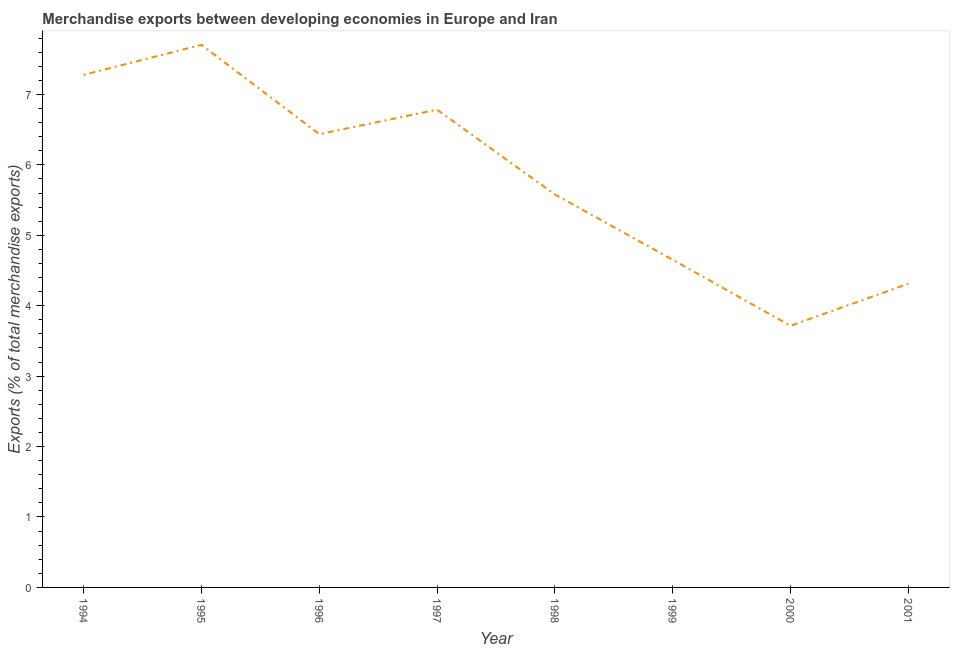What is the merchandise exports in 1994?
Make the answer very short. 7.28. Across all years, what is the maximum merchandise exports?
Your answer should be compact. 7.7. Across all years, what is the minimum merchandise exports?
Ensure brevity in your answer.  3.71. What is the sum of the merchandise exports?
Make the answer very short. 46.46. What is the difference between the merchandise exports in 1994 and 1998?
Provide a succinct answer. 1.7. What is the average merchandise exports per year?
Provide a short and direct response. 5.81. What is the median merchandise exports?
Ensure brevity in your answer.  6.01. In how many years, is the merchandise exports greater than 3.2 %?
Your answer should be very brief. 8. Do a majority of the years between 1999 and 1994 (inclusive) have merchandise exports greater than 6.6 %?
Your response must be concise. Yes. What is the ratio of the merchandise exports in 1995 to that in 2000?
Offer a terse response. 2.07. What is the difference between the highest and the second highest merchandise exports?
Offer a terse response. 0.43. What is the difference between the highest and the lowest merchandise exports?
Provide a succinct answer. 3.99. In how many years, is the merchandise exports greater than the average merchandise exports taken over all years?
Keep it short and to the point. 4. How many lines are there?
Provide a short and direct response. 1. How many years are there in the graph?
Your answer should be very brief. 8. Does the graph contain any zero values?
Your response must be concise. No. What is the title of the graph?
Your response must be concise. Merchandise exports between developing economies in Europe and Iran. What is the label or title of the Y-axis?
Make the answer very short. Exports (% of total merchandise exports). What is the Exports (% of total merchandise exports) of 1994?
Your response must be concise. 7.28. What is the Exports (% of total merchandise exports) of 1995?
Your response must be concise. 7.7. What is the Exports (% of total merchandise exports) in 1996?
Offer a very short reply. 6.44. What is the Exports (% of total merchandise exports) in 1997?
Give a very brief answer. 6.78. What is the Exports (% of total merchandise exports) in 1998?
Provide a short and direct response. 5.58. What is the Exports (% of total merchandise exports) of 1999?
Provide a succinct answer. 4.65. What is the Exports (% of total merchandise exports) in 2000?
Offer a very short reply. 3.71. What is the Exports (% of total merchandise exports) in 2001?
Your answer should be very brief. 4.31. What is the difference between the Exports (% of total merchandise exports) in 1994 and 1995?
Provide a short and direct response. -0.43. What is the difference between the Exports (% of total merchandise exports) in 1994 and 1996?
Offer a very short reply. 0.84. What is the difference between the Exports (% of total merchandise exports) in 1994 and 1997?
Offer a terse response. 0.49. What is the difference between the Exports (% of total merchandise exports) in 1994 and 1998?
Your response must be concise. 1.7. What is the difference between the Exports (% of total merchandise exports) in 1994 and 1999?
Keep it short and to the point. 2.63. What is the difference between the Exports (% of total merchandise exports) in 1994 and 2000?
Your answer should be very brief. 3.56. What is the difference between the Exports (% of total merchandise exports) in 1994 and 2001?
Provide a succinct answer. 2.97. What is the difference between the Exports (% of total merchandise exports) in 1995 and 1996?
Make the answer very short. 1.27. What is the difference between the Exports (% of total merchandise exports) in 1995 and 1997?
Provide a short and direct response. 0.92. What is the difference between the Exports (% of total merchandise exports) in 1995 and 1998?
Give a very brief answer. 2.12. What is the difference between the Exports (% of total merchandise exports) in 1995 and 1999?
Your answer should be compact. 3.05. What is the difference between the Exports (% of total merchandise exports) in 1995 and 2000?
Provide a short and direct response. 3.99. What is the difference between the Exports (% of total merchandise exports) in 1995 and 2001?
Offer a terse response. 3.39. What is the difference between the Exports (% of total merchandise exports) in 1996 and 1997?
Your answer should be compact. -0.35. What is the difference between the Exports (% of total merchandise exports) in 1996 and 1998?
Your answer should be compact. 0.86. What is the difference between the Exports (% of total merchandise exports) in 1996 and 1999?
Your answer should be compact. 1.78. What is the difference between the Exports (% of total merchandise exports) in 1996 and 2000?
Offer a terse response. 2.72. What is the difference between the Exports (% of total merchandise exports) in 1996 and 2001?
Make the answer very short. 2.13. What is the difference between the Exports (% of total merchandise exports) in 1997 and 1998?
Ensure brevity in your answer.  1.2. What is the difference between the Exports (% of total merchandise exports) in 1997 and 1999?
Ensure brevity in your answer.  2.13. What is the difference between the Exports (% of total merchandise exports) in 1997 and 2000?
Keep it short and to the point. 3.07. What is the difference between the Exports (% of total merchandise exports) in 1997 and 2001?
Offer a terse response. 2.47. What is the difference between the Exports (% of total merchandise exports) in 1998 and 1999?
Ensure brevity in your answer.  0.93. What is the difference between the Exports (% of total merchandise exports) in 1998 and 2000?
Make the answer very short. 1.87. What is the difference between the Exports (% of total merchandise exports) in 1998 and 2001?
Your answer should be very brief. 1.27. What is the difference between the Exports (% of total merchandise exports) in 1999 and 2000?
Provide a short and direct response. 0.94. What is the difference between the Exports (% of total merchandise exports) in 1999 and 2001?
Give a very brief answer. 0.34. What is the difference between the Exports (% of total merchandise exports) in 2000 and 2001?
Your response must be concise. -0.6. What is the ratio of the Exports (% of total merchandise exports) in 1994 to that in 1995?
Offer a very short reply. 0.94. What is the ratio of the Exports (% of total merchandise exports) in 1994 to that in 1996?
Keep it short and to the point. 1.13. What is the ratio of the Exports (% of total merchandise exports) in 1994 to that in 1997?
Ensure brevity in your answer.  1.07. What is the ratio of the Exports (% of total merchandise exports) in 1994 to that in 1998?
Offer a terse response. 1.3. What is the ratio of the Exports (% of total merchandise exports) in 1994 to that in 1999?
Make the answer very short. 1.56. What is the ratio of the Exports (% of total merchandise exports) in 1994 to that in 2000?
Your answer should be very brief. 1.96. What is the ratio of the Exports (% of total merchandise exports) in 1994 to that in 2001?
Your response must be concise. 1.69. What is the ratio of the Exports (% of total merchandise exports) in 1995 to that in 1996?
Make the answer very short. 1.2. What is the ratio of the Exports (% of total merchandise exports) in 1995 to that in 1997?
Keep it short and to the point. 1.14. What is the ratio of the Exports (% of total merchandise exports) in 1995 to that in 1998?
Your answer should be compact. 1.38. What is the ratio of the Exports (% of total merchandise exports) in 1995 to that in 1999?
Ensure brevity in your answer.  1.66. What is the ratio of the Exports (% of total merchandise exports) in 1995 to that in 2000?
Your answer should be very brief. 2.07. What is the ratio of the Exports (% of total merchandise exports) in 1995 to that in 2001?
Your response must be concise. 1.79. What is the ratio of the Exports (% of total merchandise exports) in 1996 to that in 1997?
Your answer should be very brief. 0.95. What is the ratio of the Exports (% of total merchandise exports) in 1996 to that in 1998?
Ensure brevity in your answer.  1.15. What is the ratio of the Exports (% of total merchandise exports) in 1996 to that in 1999?
Your answer should be very brief. 1.38. What is the ratio of the Exports (% of total merchandise exports) in 1996 to that in 2000?
Keep it short and to the point. 1.73. What is the ratio of the Exports (% of total merchandise exports) in 1996 to that in 2001?
Make the answer very short. 1.49. What is the ratio of the Exports (% of total merchandise exports) in 1997 to that in 1998?
Make the answer very short. 1.22. What is the ratio of the Exports (% of total merchandise exports) in 1997 to that in 1999?
Provide a short and direct response. 1.46. What is the ratio of the Exports (% of total merchandise exports) in 1997 to that in 2000?
Make the answer very short. 1.83. What is the ratio of the Exports (% of total merchandise exports) in 1997 to that in 2001?
Ensure brevity in your answer.  1.57. What is the ratio of the Exports (% of total merchandise exports) in 1998 to that in 1999?
Offer a very short reply. 1.2. What is the ratio of the Exports (% of total merchandise exports) in 1998 to that in 2000?
Offer a very short reply. 1.5. What is the ratio of the Exports (% of total merchandise exports) in 1998 to that in 2001?
Offer a terse response. 1.29. What is the ratio of the Exports (% of total merchandise exports) in 1999 to that in 2000?
Your answer should be very brief. 1.25. What is the ratio of the Exports (% of total merchandise exports) in 1999 to that in 2001?
Give a very brief answer. 1.08. What is the ratio of the Exports (% of total merchandise exports) in 2000 to that in 2001?
Ensure brevity in your answer.  0.86. 